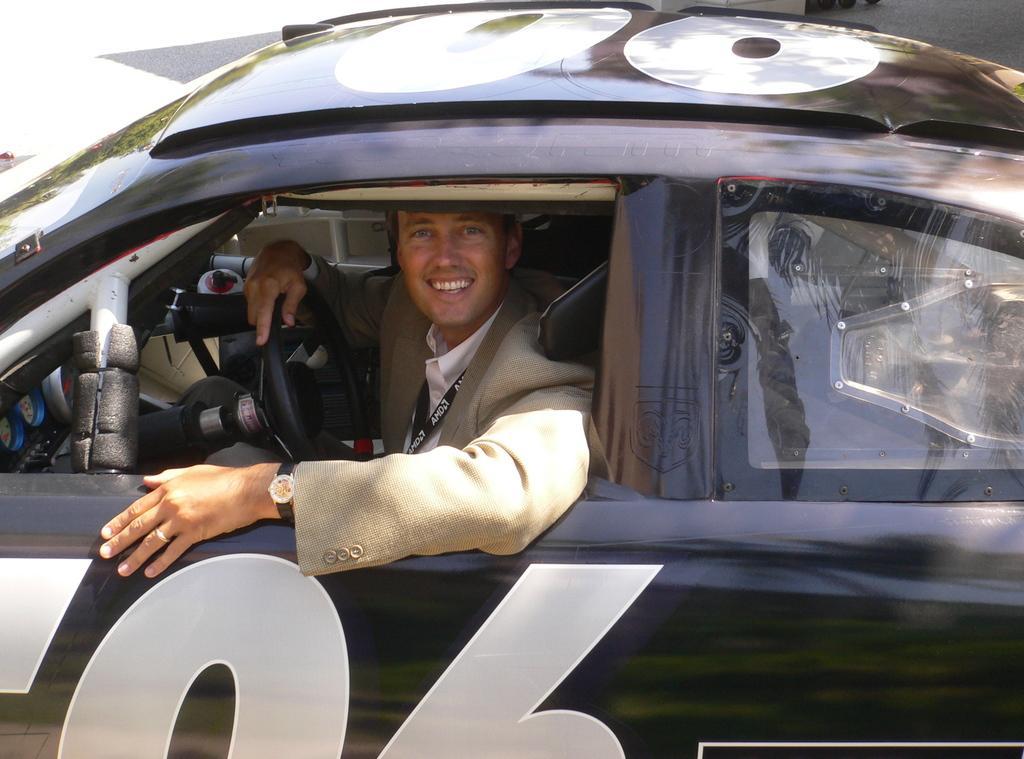Can you describe this image briefly? This is the picture on the road. There is a person sitting inside the black car and he is smiling and he is holding the steering. 